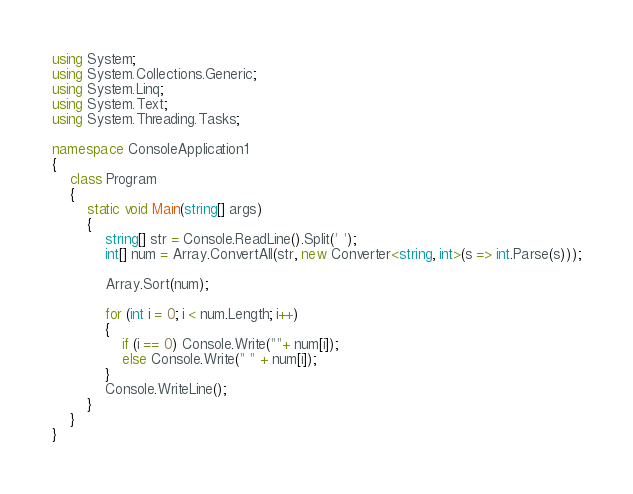Convert code to text. <code><loc_0><loc_0><loc_500><loc_500><_C#_>using System;
using System.Collections.Generic;
using System.Linq;
using System.Text;
using System.Threading.Tasks;

namespace ConsoleApplication1
{
    class Program
    {
        static void Main(string[] args)
        {
            string[] str = Console.ReadLine().Split(' ');
            int[] num = Array.ConvertAll(str, new Converter<string, int>(s => int.Parse(s)));

            Array.Sort(num);

            for (int i = 0; i < num.Length; i++)
            {
                if (i == 0) Console.Write(""+ num[i]);
                else Console.Write(" " + num[i]);
            }
            Console.WriteLine();
        }
    }
}</code> 